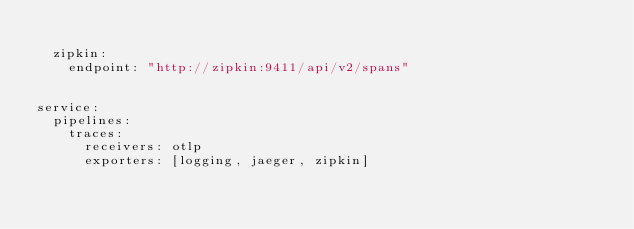Convert code to text. <code><loc_0><loc_0><loc_500><loc_500><_YAML_>
  zipkin:
    endpoint: "http://zipkin:9411/api/v2/spans"


service:
  pipelines:
    traces:
      receivers: otlp
      exporters: [logging, jaeger, zipkin]
</code> 